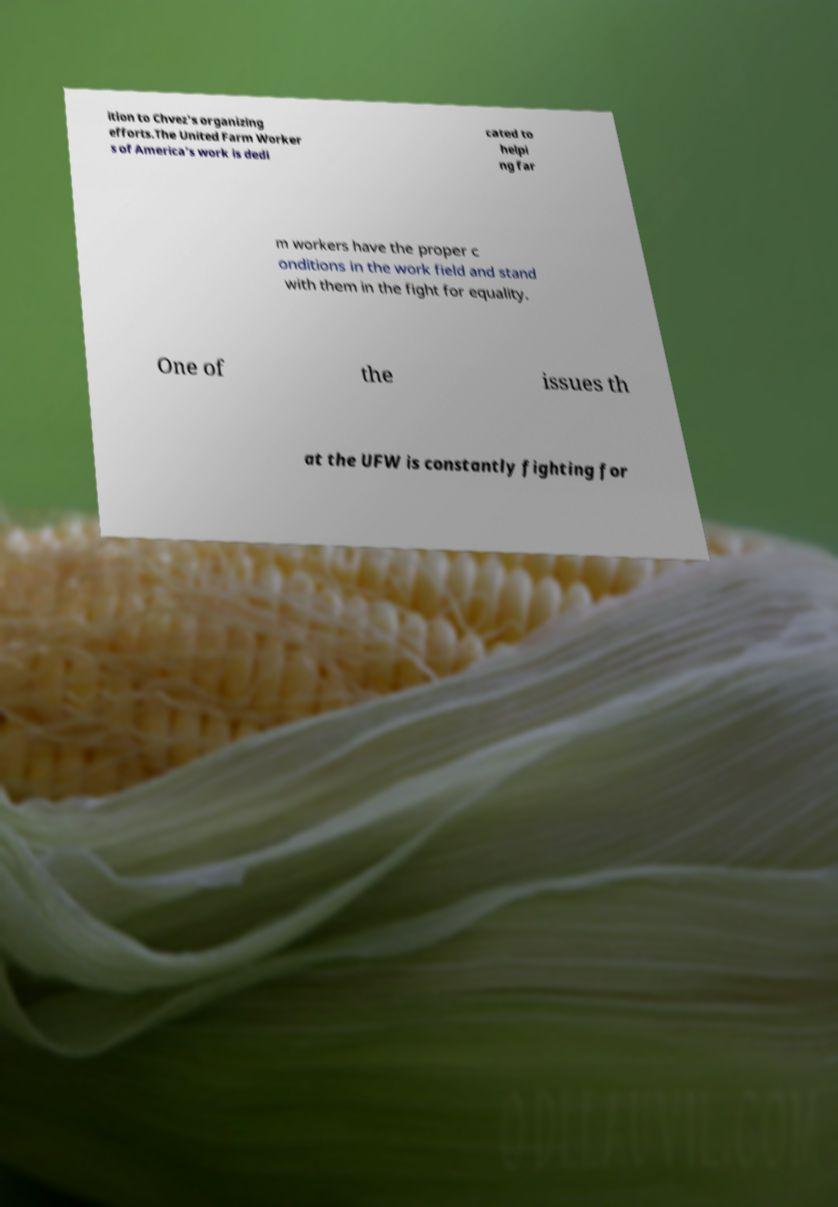Can you accurately transcribe the text from the provided image for me? ition to Chvez's organizing efforts.The United Farm Worker s of America’s work is dedi cated to helpi ng far m workers have the proper c onditions in the work field and stand with them in the fight for equality. One of the issues th at the UFW is constantly fighting for 